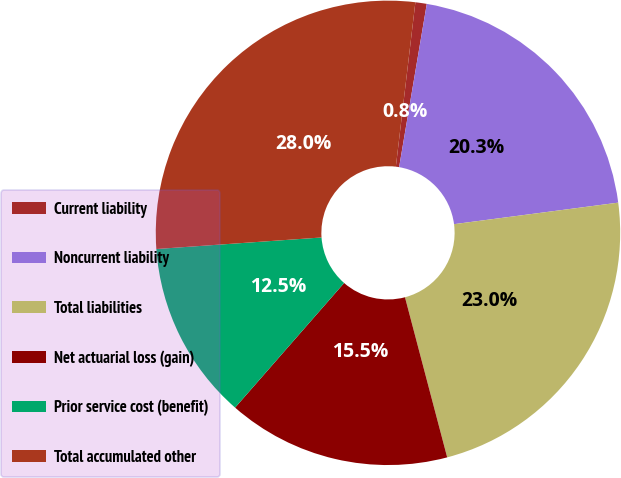Convert chart. <chart><loc_0><loc_0><loc_500><loc_500><pie_chart><fcel>Current liability<fcel>Noncurrent liability<fcel>Total liabilities<fcel>Net actuarial loss (gain)<fcel>Prior service cost (benefit)<fcel>Total accumulated other<nl><fcel>0.79%<fcel>20.25%<fcel>22.97%<fcel>15.54%<fcel>12.45%<fcel>27.99%<nl></chart> 